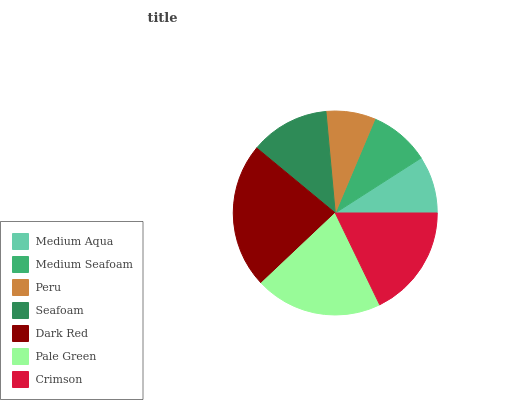Is Peru the minimum?
Answer yes or no. Yes. Is Dark Red the maximum?
Answer yes or no. Yes. Is Medium Seafoam the minimum?
Answer yes or no. No. Is Medium Seafoam the maximum?
Answer yes or no. No. Is Medium Seafoam greater than Medium Aqua?
Answer yes or no. Yes. Is Medium Aqua less than Medium Seafoam?
Answer yes or no. Yes. Is Medium Aqua greater than Medium Seafoam?
Answer yes or no. No. Is Medium Seafoam less than Medium Aqua?
Answer yes or no. No. Is Seafoam the high median?
Answer yes or no. Yes. Is Seafoam the low median?
Answer yes or no. Yes. Is Crimson the high median?
Answer yes or no. No. Is Crimson the low median?
Answer yes or no. No. 